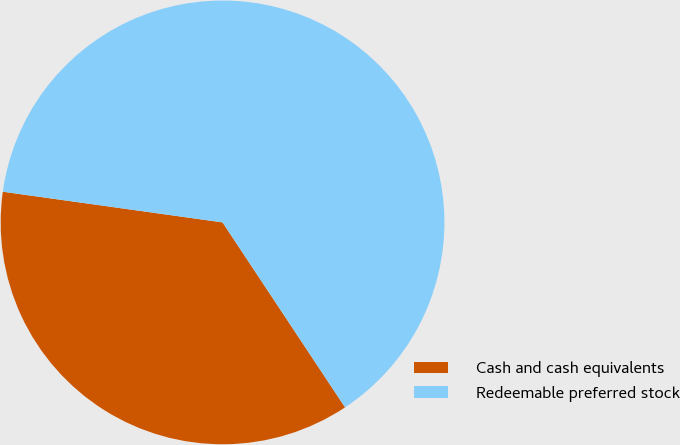<chart> <loc_0><loc_0><loc_500><loc_500><pie_chart><fcel>Cash and cash equivalents<fcel>Redeemable preferred stock<nl><fcel>36.52%<fcel>63.48%<nl></chart> 